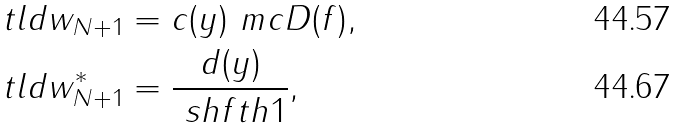<formula> <loc_0><loc_0><loc_500><loc_500>\ t l d { w } _ { N + 1 } & = c ( y ) \ m c { D } ( f ) , \\ \ t l d { w } _ { N + 1 } ^ { * } & = \frac { d ( y ) } { \ s h f t { h } { 1 } } ,</formula> 